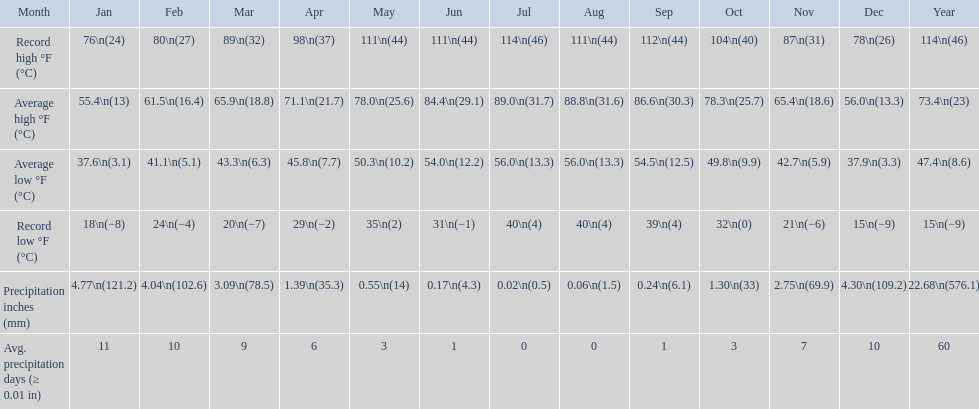In which month did the average high temperature reach 8 July. 